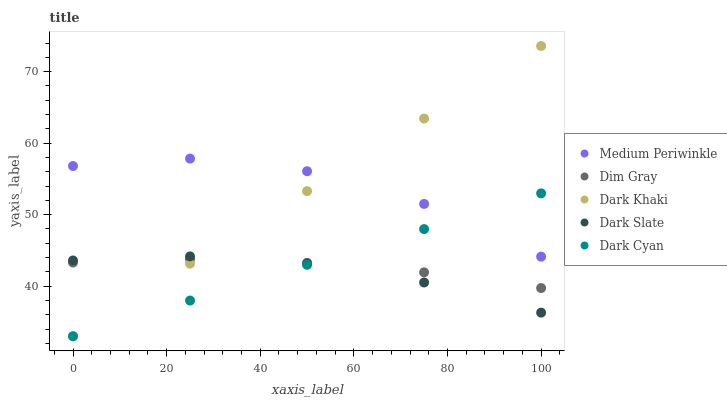Does Dark Slate have the minimum area under the curve?
Answer yes or no. Yes. Does Medium Periwinkle have the maximum area under the curve?
Answer yes or no. Yes. Does Dim Gray have the minimum area under the curve?
Answer yes or no. No. Does Dim Gray have the maximum area under the curve?
Answer yes or no. No. Is Dark Khaki the smoothest?
Answer yes or no. Yes. Is Medium Periwinkle the roughest?
Answer yes or no. Yes. Is Dark Slate the smoothest?
Answer yes or no. No. Is Dark Slate the roughest?
Answer yes or no. No. Does Dark Khaki have the lowest value?
Answer yes or no. Yes. Does Dark Slate have the lowest value?
Answer yes or no. No. Does Dark Khaki have the highest value?
Answer yes or no. Yes. Does Dark Slate have the highest value?
Answer yes or no. No. Is Dark Slate less than Medium Periwinkle?
Answer yes or no. Yes. Is Medium Periwinkle greater than Dim Gray?
Answer yes or no. Yes. Does Dark Cyan intersect Dim Gray?
Answer yes or no. Yes. Is Dark Cyan less than Dim Gray?
Answer yes or no. No. Is Dark Cyan greater than Dim Gray?
Answer yes or no. No. Does Dark Slate intersect Medium Periwinkle?
Answer yes or no. No. 